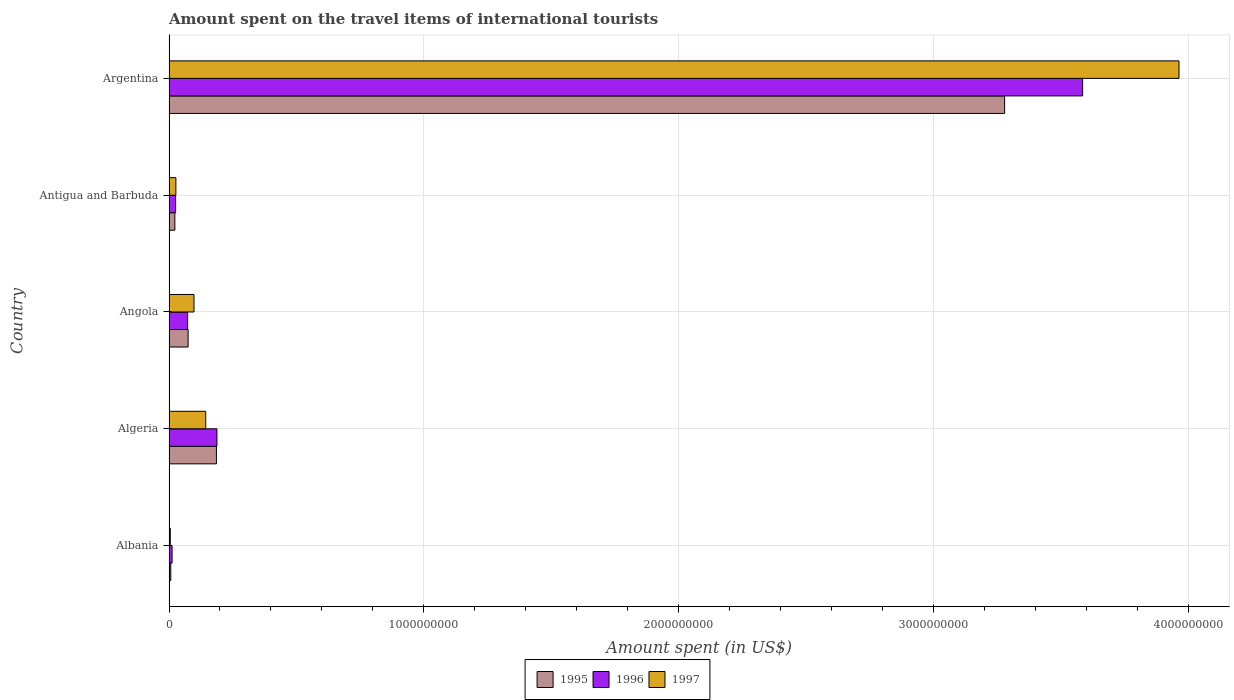Are the number of bars on each tick of the Y-axis equal?
Provide a short and direct response. Yes. What is the label of the 5th group of bars from the top?
Ensure brevity in your answer.  Albania. In how many cases, is the number of bars for a given country not equal to the number of legend labels?
Make the answer very short. 0. Across all countries, what is the maximum amount spent on the travel items of international tourists in 1997?
Give a very brief answer. 3.96e+09. Across all countries, what is the minimum amount spent on the travel items of international tourists in 1997?
Make the answer very short. 5.00e+06. In which country was the amount spent on the travel items of international tourists in 1996 maximum?
Your answer should be very brief. Argentina. In which country was the amount spent on the travel items of international tourists in 1996 minimum?
Provide a short and direct response. Albania. What is the total amount spent on the travel items of international tourists in 1997 in the graph?
Give a very brief answer. 4.24e+09. What is the difference between the amount spent on the travel items of international tourists in 1995 in Angola and that in Antigua and Barbuda?
Give a very brief answer. 5.20e+07. What is the difference between the amount spent on the travel items of international tourists in 1995 in Algeria and the amount spent on the travel items of international tourists in 1997 in Angola?
Give a very brief answer. 8.80e+07. What is the average amount spent on the travel items of international tourists in 1995 per country?
Give a very brief answer. 7.14e+08. What is the ratio of the amount spent on the travel items of international tourists in 1996 in Albania to that in Antigua and Barbuda?
Keep it short and to the point. 0.46. Is the amount spent on the travel items of international tourists in 1995 in Albania less than that in Algeria?
Provide a short and direct response. Yes. What is the difference between the highest and the second highest amount spent on the travel items of international tourists in 1996?
Offer a very short reply. 3.40e+09. What is the difference between the highest and the lowest amount spent on the travel items of international tourists in 1996?
Keep it short and to the point. 3.57e+09. In how many countries, is the amount spent on the travel items of international tourists in 1995 greater than the average amount spent on the travel items of international tourists in 1995 taken over all countries?
Provide a succinct answer. 1. What does the 2nd bar from the top in Albania represents?
Your response must be concise. 1996. What does the 2nd bar from the bottom in Albania represents?
Give a very brief answer. 1996. Is it the case that in every country, the sum of the amount spent on the travel items of international tourists in 1996 and amount spent on the travel items of international tourists in 1995 is greater than the amount spent on the travel items of international tourists in 1997?
Ensure brevity in your answer.  Yes. How many bars are there?
Keep it short and to the point. 15. What is the difference between two consecutive major ticks on the X-axis?
Make the answer very short. 1.00e+09. Where does the legend appear in the graph?
Keep it short and to the point. Bottom center. How many legend labels are there?
Offer a very short reply. 3. How are the legend labels stacked?
Your answer should be very brief. Horizontal. What is the title of the graph?
Keep it short and to the point. Amount spent on the travel items of international tourists. Does "2003" appear as one of the legend labels in the graph?
Ensure brevity in your answer.  No. What is the label or title of the X-axis?
Your answer should be very brief. Amount spent (in US$). What is the label or title of the Y-axis?
Make the answer very short. Country. What is the Amount spent (in US$) of 1995 in Albania?
Your answer should be very brief. 7.00e+06. What is the Amount spent (in US$) in 1996 in Albania?
Give a very brief answer. 1.20e+07. What is the Amount spent (in US$) of 1995 in Algeria?
Make the answer very short. 1.86e+08. What is the Amount spent (in US$) of 1996 in Algeria?
Keep it short and to the point. 1.88e+08. What is the Amount spent (in US$) in 1997 in Algeria?
Your response must be concise. 1.44e+08. What is the Amount spent (in US$) in 1995 in Angola?
Give a very brief answer. 7.50e+07. What is the Amount spent (in US$) of 1996 in Angola?
Provide a succinct answer. 7.30e+07. What is the Amount spent (in US$) in 1997 in Angola?
Provide a succinct answer. 9.80e+07. What is the Amount spent (in US$) in 1995 in Antigua and Barbuda?
Your answer should be compact. 2.30e+07. What is the Amount spent (in US$) of 1996 in Antigua and Barbuda?
Your answer should be compact. 2.60e+07. What is the Amount spent (in US$) in 1997 in Antigua and Barbuda?
Offer a terse response. 2.70e+07. What is the Amount spent (in US$) of 1995 in Argentina?
Keep it short and to the point. 3.28e+09. What is the Amount spent (in US$) of 1996 in Argentina?
Offer a terse response. 3.58e+09. What is the Amount spent (in US$) in 1997 in Argentina?
Give a very brief answer. 3.96e+09. Across all countries, what is the maximum Amount spent (in US$) of 1995?
Offer a very short reply. 3.28e+09. Across all countries, what is the maximum Amount spent (in US$) of 1996?
Provide a short and direct response. 3.58e+09. Across all countries, what is the maximum Amount spent (in US$) of 1997?
Your answer should be very brief. 3.96e+09. Across all countries, what is the minimum Amount spent (in US$) in 1995?
Keep it short and to the point. 7.00e+06. What is the total Amount spent (in US$) in 1995 in the graph?
Provide a short and direct response. 3.57e+09. What is the total Amount spent (in US$) of 1996 in the graph?
Keep it short and to the point. 3.88e+09. What is the total Amount spent (in US$) of 1997 in the graph?
Provide a succinct answer. 4.24e+09. What is the difference between the Amount spent (in US$) of 1995 in Albania and that in Algeria?
Make the answer very short. -1.79e+08. What is the difference between the Amount spent (in US$) in 1996 in Albania and that in Algeria?
Give a very brief answer. -1.76e+08. What is the difference between the Amount spent (in US$) of 1997 in Albania and that in Algeria?
Your answer should be compact. -1.39e+08. What is the difference between the Amount spent (in US$) in 1995 in Albania and that in Angola?
Make the answer very short. -6.80e+07. What is the difference between the Amount spent (in US$) of 1996 in Albania and that in Angola?
Ensure brevity in your answer.  -6.10e+07. What is the difference between the Amount spent (in US$) of 1997 in Albania and that in Angola?
Your answer should be compact. -9.30e+07. What is the difference between the Amount spent (in US$) of 1995 in Albania and that in Antigua and Barbuda?
Keep it short and to the point. -1.60e+07. What is the difference between the Amount spent (in US$) in 1996 in Albania and that in Antigua and Barbuda?
Provide a short and direct response. -1.40e+07. What is the difference between the Amount spent (in US$) of 1997 in Albania and that in Antigua and Barbuda?
Provide a succinct answer. -2.20e+07. What is the difference between the Amount spent (in US$) in 1995 in Albania and that in Argentina?
Your answer should be very brief. -3.27e+09. What is the difference between the Amount spent (in US$) of 1996 in Albania and that in Argentina?
Provide a succinct answer. -3.57e+09. What is the difference between the Amount spent (in US$) of 1997 in Albania and that in Argentina?
Your answer should be compact. -3.96e+09. What is the difference between the Amount spent (in US$) in 1995 in Algeria and that in Angola?
Provide a short and direct response. 1.11e+08. What is the difference between the Amount spent (in US$) of 1996 in Algeria and that in Angola?
Your answer should be compact. 1.15e+08. What is the difference between the Amount spent (in US$) of 1997 in Algeria and that in Angola?
Your answer should be compact. 4.60e+07. What is the difference between the Amount spent (in US$) of 1995 in Algeria and that in Antigua and Barbuda?
Give a very brief answer. 1.63e+08. What is the difference between the Amount spent (in US$) in 1996 in Algeria and that in Antigua and Barbuda?
Ensure brevity in your answer.  1.62e+08. What is the difference between the Amount spent (in US$) of 1997 in Algeria and that in Antigua and Barbuda?
Offer a terse response. 1.17e+08. What is the difference between the Amount spent (in US$) in 1995 in Algeria and that in Argentina?
Offer a terse response. -3.09e+09. What is the difference between the Amount spent (in US$) in 1996 in Algeria and that in Argentina?
Provide a short and direct response. -3.40e+09. What is the difference between the Amount spent (in US$) of 1997 in Algeria and that in Argentina?
Your answer should be very brief. -3.82e+09. What is the difference between the Amount spent (in US$) of 1995 in Angola and that in Antigua and Barbuda?
Offer a very short reply. 5.20e+07. What is the difference between the Amount spent (in US$) in 1996 in Angola and that in Antigua and Barbuda?
Your answer should be compact. 4.70e+07. What is the difference between the Amount spent (in US$) of 1997 in Angola and that in Antigua and Barbuda?
Offer a terse response. 7.10e+07. What is the difference between the Amount spent (in US$) in 1995 in Angola and that in Argentina?
Offer a terse response. -3.20e+09. What is the difference between the Amount spent (in US$) in 1996 in Angola and that in Argentina?
Your answer should be compact. -3.51e+09. What is the difference between the Amount spent (in US$) of 1997 in Angola and that in Argentina?
Your answer should be compact. -3.86e+09. What is the difference between the Amount spent (in US$) of 1995 in Antigua and Barbuda and that in Argentina?
Your answer should be compact. -3.26e+09. What is the difference between the Amount spent (in US$) in 1996 in Antigua and Barbuda and that in Argentina?
Ensure brevity in your answer.  -3.56e+09. What is the difference between the Amount spent (in US$) in 1997 in Antigua and Barbuda and that in Argentina?
Keep it short and to the point. -3.94e+09. What is the difference between the Amount spent (in US$) in 1995 in Albania and the Amount spent (in US$) in 1996 in Algeria?
Give a very brief answer. -1.81e+08. What is the difference between the Amount spent (in US$) of 1995 in Albania and the Amount spent (in US$) of 1997 in Algeria?
Make the answer very short. -1.37e+08. What is the difference between the Amount spent (in US$) in 1996 in Albania and the Amount spent (in US$) in 1997 in Algeria?
Ensure brevity in your answer.  -1.32e+08. What is the difference between the Amount spent (in US$) of 1995 in Albania and the Amount spent (in US$) of 1996 in Angola?
Your answer should be compact. -6.60e+07. What is the difference between the Amount spent (in US$) of 1995 in Albania and the Amount spent (in US$) of 1997 in Angola?
Provide a short and direct response. -9.10e+07. What is the difference between the Amount spent (in US$) of 1996 in Albania and the Amount spent (in US$) of 1997 in Angola?
Keep it short and to the point. -8.60e+07. What is the difference between the Amount spent (in US$) in 1995 in Albania and the Amount spent (in US$) in 1996 in Antigua and Barbuda?
Make the answer very short. -1.90e+07. What is the difference between the Amount spent (in US$) in 1995 in Albania and the Amount spent (in US$) in 1997 in Antigua and Barbuda?
Keep it short and to the point. -2.00e+07. What is the difference between the Amount spent (in US$) in 1996 in Albania and the Amount spent (in US$) in 1997 in Antigua and Barbuda?
Provide a short and direct response. -1.50e+07. What is the difference between the Amount spent (in US$) of 1995 in Albania and the Amount spent (in US$) of 1996 in Argentina?
Your response must be concise. -3.58e+09. What is the difference between the Amount spent (in US$) of 1995 in Albania and the Amount spent (in US$) of 1997 in Argentina?
Ensure brevity in your answer.  -3.96e+09. What is the difference between the Amount spent (in US$) of 1996 in Albania and the Amount spent (in US$) of 1997 in Argentina?
Your response must be concise. -3.95e+09. What is the difference between the Amount spent (in US$) of 1995 in Algeria and the Amount spent (in US$) of 1996 in Angola?
Offer a very short reply. 1.13e+08. What is the difference between the Amount spent (in US$) of 1995 in Algeria and the Amount spent (in US$) of 1997 in Angola?
Your answer should be very brief. 8.80e+07. What is the difference between the Amount spent (in US$) in 1996 in Algeria and the Amount spent (in US$) in 1997 in Angola?
Your response must be concise. 9.00e+07. What is the difference between the Amount spent (in US$) of 1995 in Algeria and the Amount spent (in US$) of 1996 in Antigua and Barbuda?
Provide a succinct answer. 1.60e+08. What is the difference between the Amount spent (in US$) in 1995 in Algeria and the Amount spent (in US$) in 1997 in Antigua and Barbuda?
Ensure brevity in your answer.  1.59e+08. What is the difference between the Amount spent (in US$) of 1996 in Algeria and the Amount spent (in US$) of 1997 in Antigua and Barbuda?
Your answer should be very brief. 1.61e+08. What is the difference between the Amount spent (in US$) of 1995 in Algeria and the Amount spent (in US$) of 1996 in Argentina?
Offer a very short reply. -3.40e+09. What is the difference between the Amount spent (in US$) in 1995 in Algeria and the Amount spent (in US$) in 1997 in Argentina?
Your answer should be very brief. -3.78e+09. What is the difference between the Amount spent (in US$) in 1996 in Algeria and the Amount spent (in US$) in 1997 in Argentina?
Make the answer very short. -3.77e+09. What is the difference between the Amount spent (in US$) in 1995 in Angola and the Amount spent (in US$) in 1996 in Antigua and Barbuda?
Keep it short and to the point. 4.90e+07. What is the difference between the Amount spent (in US$) in 1995 in Angola and the Amount spent (in US$) in 1997 in Antigua and Barbuda?
Make the answer very short. 4.80e+07. What is the difference between the Amount spent (in US$) of 1996 in Angola and the Amount spent (in US$) of 1997 in Antigua and Barbuda?
Your response must be concise. 4.60e+07. What is the difference between the Amount spent (in US$) of 1995 in Angola and the Amount spent (in US$) of 1996 in Argentina?
Offer a terse response. -3.51e+09. What is the difference between the Amount spent (in US$) in 1995 in Angola and the Amount spent (in US$) in 1997 in Argentina?
Offer a very short reply. -3.89e+09. What is the difference between the Amount spent (in US$) of 1996 in Angola and the Amount spent (in US$) of 1997 in Argentina?
Ensure brevity in your answer.  -3.89e+09. What is the difference between the Amount spent (in US$) of 1995 in Antigua and Barbuda and the Amount spent (in US$) of 1996 in Argentina?
Offer a terse response. -3.56e+09. What is the difference between the Amount spent (in US$) of 1995 in Antigua and Barbuda and the Amount spent (in US$) of 1997 in Argentina?
Offer a terse response. -3.94e+09. What is the difference between the Amount spent (in US$) in 1996 in Antigua and Barbuda and the Amount spent (in US$) in 1997 in Argentina?
Ensure brevity in your answer.  -3.94e+09. What is the average Amount spent (in US$) of 1995 per country?
Your response must be concise. 7.14e+08. What is the average Amount spent (in US$) of 1996 per country?
Give a very brief answer. 7.77e+08. What is the average Amount spent (in US$) of 1997 per country?
Provide a succinct answer. 8.47e+08. What is the difference between the Amount spent (in US$) of 1995 and Amount spent (in US$) of 1996 in Albania?
Provide a short and direct response. -5.00e+06. What is the difference between the Amount spent (in US$) in 1995 and Amount spent (in US$) in 1997 in Albania?
Keep it short and to the point. 2.00e+06. What is the difference between the Amount spent (in US$) of 1995 and Amount spent (in US$) of 1996 in Algeria?
Your response must be concise. -2.00e+06. What is the difference between the Amount spent (in US$) in 1995 and Amount spent (in US$) in 1997 in Algeria?
Offer a terse response. 4.20e+07. What is the difference between the Amount spent (in US$) in 1996 and Amount spent (in US$) in 1997 in Algeria?
Provide a succinct answer. 4.40e+07. What is the difference between the Amount spent (in US$) in 1995 and Amount spent (in US$) in 1996 in Angola?
Keep it short and to the point. 2.00e+06. What is the difference between the Amount spent (in US$) in 1995 and Amount spent (in US$) in 1997 in Angola?
Your answer should be very brief. -2.30e+07. What is the difference between the Amount spent (in US$) of 1996 and Amount spent (in US$) of 1997 in Angola?
Offer a very short reply. -2.50e+07. What is the difference between the Amount spent (in US$) in 1995 and Amount spent (in US$) in 1997 in Antigua and Barbuda?
Ensure brevity in your answer.  -4.00e+06. What is the difference between the Amount spent (in US$) in 1995 and Amount spent (in US$) in 1996 in Argentina?
Your answer should be very brief. -3.06e+08. What is the difference between the Amount spent (in US$) of 1995 and Amount spent (in US$) of 1997 in Argentina?
Offer a very short reply. -6.84e+08. What is the difference between the Amount spent (in US$) of 1996 and Amount spent (in US$) of 1997 in Argentina?
Provide a short and direct response. -3.78e+08. What is the ratio of the Amount spent (in US$) in 1995 in Albania to that in Algeria?
Offer a very short reply. 0.04. What is the ratio of the Amount spent (in US$) of 1996 in Albania to that in Algeria?
Ensure brevity in your answer.  0.06. What is the ratio of the Amount spent (in US$) of 1997 in Albania to that in Algeria?
Your answer should be very brief. 0.03. What is the ratio of the Amount spent (in US$) of 1995 in Albania to that in Angola?
Your response must be concise. 0.09. What is the ratio of the Amount spent (in US$) of 1996 in Albania to that in Angola?
Your response must be concise. 0.16. What is the ratio of the Amount spent (in US$) in 1997 in Albania to that in Angola?
Provide a succinct answer. 0.05. What is the ratio of the Amount spent (in US$) of 1995 in Albania to that in Antigua and Barbuda?
Give a very brief answer. 0.3. What is the ratio of the Amount spent (in US$) in 1996 in Albania to that in Antigua and Barbuda?
Provide a short and direct response. 0.46. What is the ratio of the Amount spent (in US$) of 1997 in Albania to that in Antigua and Barbuda?
Offer a terse response. 0.19. What is the ratio of the Amount spent (in US$) of 1995 in Albania to that in Argentina?
Keep it short and to the point. 0. What is the ratio of the Amount spent (in US$) in 1996 in Albania to that in Argentina?
Offer a very short reply. 0. What is the ratio of the Amount spent (in US$) in 1997 in Albania to that in Argentina?
Ensure brevity in your answer.  0. What is the ratio of the Amount spent (in US$) of 1995 in Algeria to that in Angola?
Your response must be concise. 2.48. What is the ratio of the Amount spent (in US$) in 1996 in Algeria to that in Angola?
Offer a terse response. 2.58. What is the ratio of the Amount spent (in US$) of 1997 in Algeria to that in Angola?
Keep it short and to the point. 1.47. What is the ratio of the Amount spent (in US$) in 1995 in Algeria to that in Antigua and Barbuda?
Offer a very short reply. 8.09. What is the ratio of the Amount spent (in US$) in 1996 in Algeria to that in Antigua and Barbuda?
Your answer should be compact. 7.23. What is the ratio of the Amount spent (in US$) of 1997 in Algeria to that in Antigua and Barbuda?
Your response must be concise. 5.33. What is the ratio of the Amount spent (in US$) of 1995 in Algeria to that in Argentina?
Your answer should be compact. 0.06. What is the ratio of the Amount spent (in US$) in 1996 in Algeria to that in Argentina?
Make the answer very short. 0.05. What is the ratio of the Amount spent (in US$) in 1997 in Algeria to that in Argentina?
Offer a terse response. 0.04. What is the ratio of the Amount spent (in US$) of 1995 in Angola to that in Antigua and Barbuda?
Give a very brief answer. 3.26. What is the ratio of the Amount spent (in US$) of 1996 in Angola to that in Antigua and Barbuda?
Offer a very short reply. 2.81. What is the ratio of the Amount spent (in US$) of 1997 in Angola to that in Antigua and Barbuda?
Keep it short and to the point. 3.63. What is the ratio of the Amount spent (in US$) in 1995 in Angola to that in Argentina?
Your answer should be very brief. 0.02. What is the ratio of the Amount spent (in US$) in 1996 in Angola to that in Argentina?
Offer a terse response. 0.02. What is the ratio of the Amount spent (in US$) in 1997 in Angola to that in Argentina?
Offer a very short reply. 0.02. What is the ratio of the Amount spent (in US$) of 1995 in Antigua and Barbuda to that in Argentina?
Ensure brevity in your answer.  0.01. What is the ratio of the Amount spent (in US$) of 1996 in Antigua and Barbuda to that in Argentina?
Offer a very short reply. 0.01. What is the ratio of the Amount spent (in US$) of 1997 in Antigua and Barbuda to that in Argentina?
Ensure brevity in your answer.  0.01. What is the difference between the highest and the second highest Amount spent (in US$) in 1995?
Your response must be concise. 3.09e+09. What is the difference between the highest and the second highest Amount spent (in US$) in 1996?
Provide a short and direct response. 3.40e+09. What is the difference between the highest and the second highest Amount spent (in US$) of 1997?
Make the answer very short. 3.82e+09. What is the difference between the highest and the lowest Amount spent (in US$) in 1995?
Your answer should be compact. 3.27e+09. What is the difference between the highest and the lowest Amount spent (in US$) of 1996?
Keep it short and to the point. 3.57e+09. What is the difference between the highest and the lowest Amount spent (in US$) of 1997?
Offer a very short reply. 3.96e+09. 